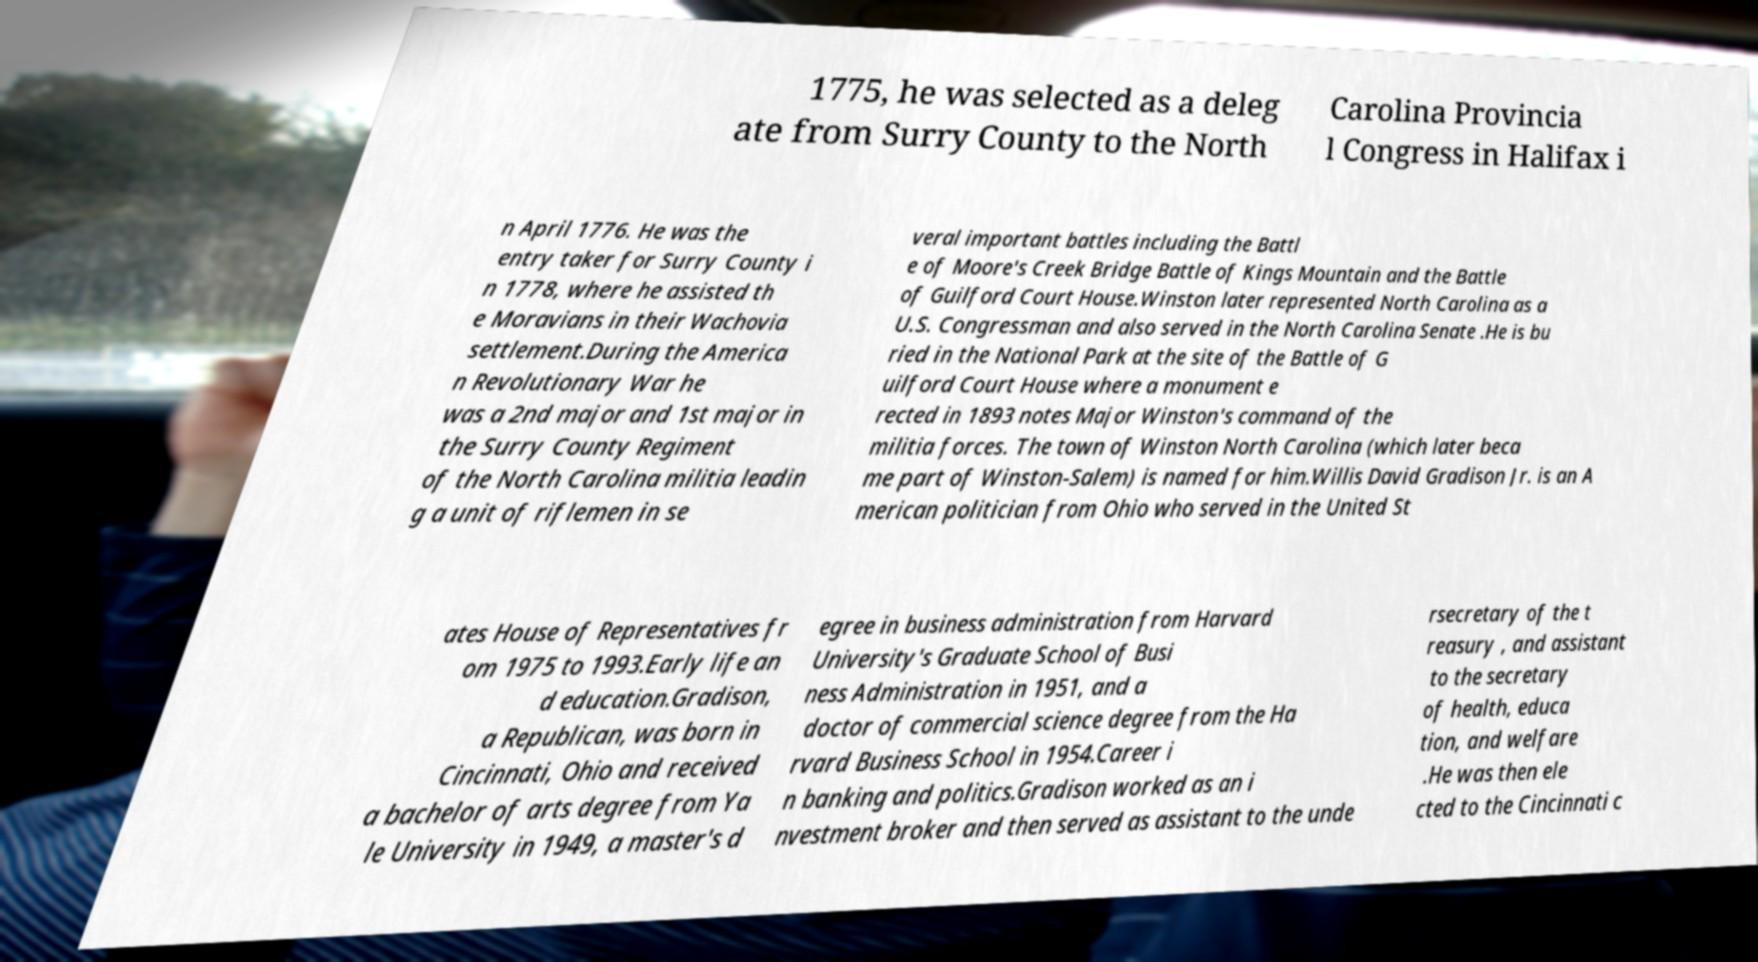For documentation purposes, I need the text within this image transcribed. Could you provide that? 1775, he was selected as a deleg ate from Surry County to the North Carolina Provincia l Congress in Halifax i n April 1776. He was the entry taker for Surry County i n 1778, where he assisted th e Moravians in their Wachovia settlement.During the America n Revolutionary War he was a 2nd major and 1st major in the Surry County Regiment of the North Carolina militia leadin g a unit of riflemen in se veral important battles including the Battl e of Moore's Creek Bridge Battle of Kings Mountain and the Battle of Guilford Court House.Winston later represented North Carolina as a U.S. Congressman and also served in the North Carolina Senate .He is bu ried in the National Park at the site of the Battle of G uilford Court House where a monument e rected in 1893 notes Major Winston's command of the militia forces. The town of Winston North Carolina (which later beca me part of Winston-Salem) is named for him.Willis David Gradison Jr. is an A merican politician from Ohio who served in the United St ates House of Representatives fr om 1975 to 1993.Early life an d education.Gradison, a Republican, was born in Cincinnati, Ohio and received a bachelor of arts degree from Ya le University in 1949, a master's d egree in business administration from Harvard University's Graduate School of Busi ness Administration in 1951, and a doctor of commercial science degree from the Ha rvard Business School in 1954.Career i n banking and politics.Gradison worked as an i nvestment broker and then served as assistant to the unde rsecretary of the t reasury , and assistant to the secretary of health, educa tion, and welfare .He was then ele cted to the Cincinnati c 